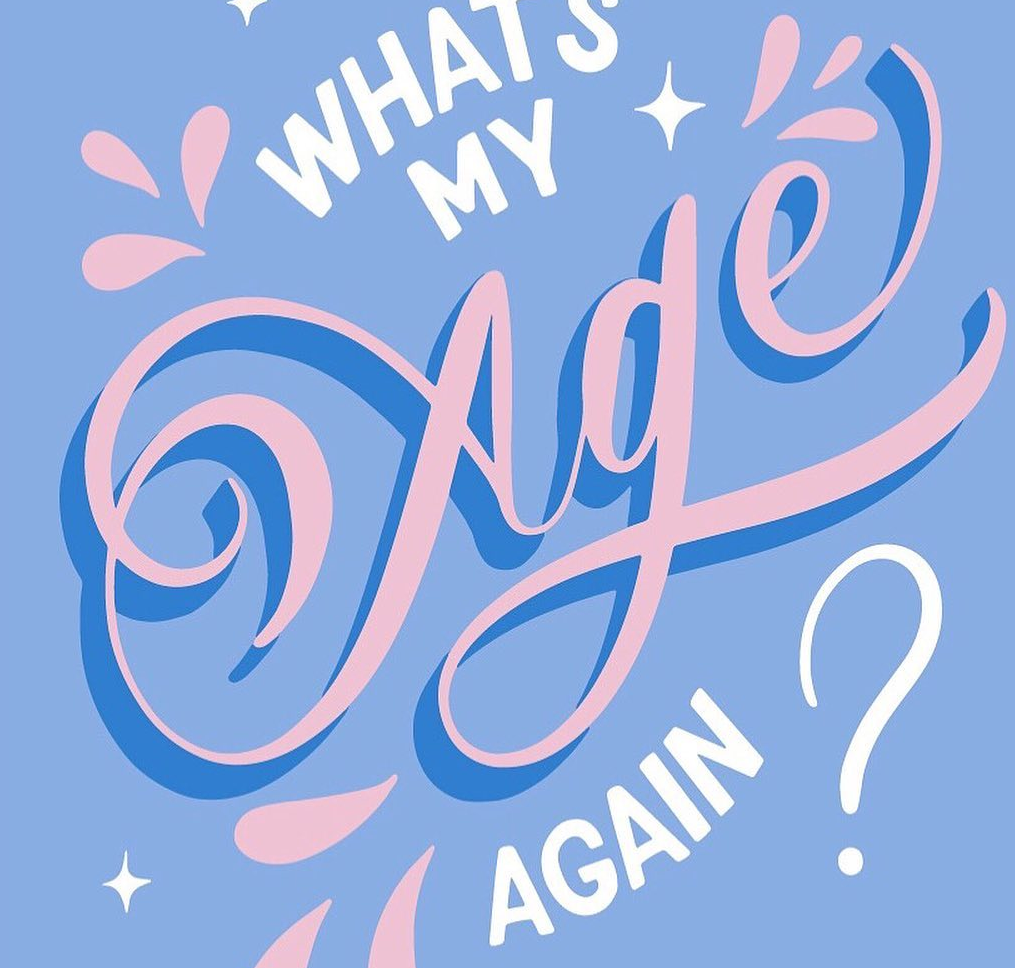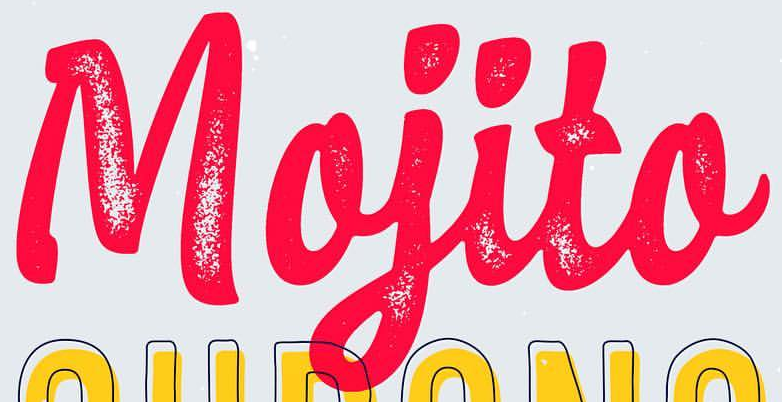Read the text from these images in sequence, separated by a semicolon. Age; Mojito 